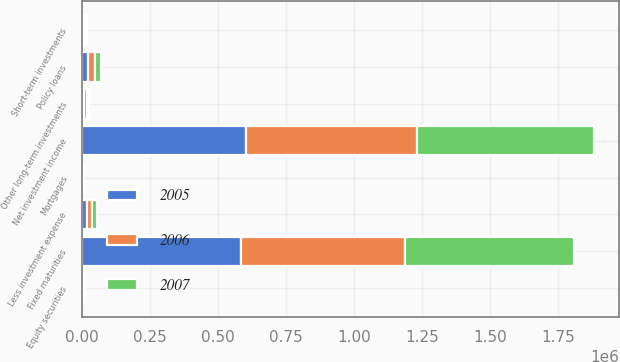Convert chart. <chart><loc_0><loc_0><loc_500><loc_500><stacked_bar_chart><ecel><fcel>Fixed maturities<fcel>Equity securities<fcel>Policy loans<fcel>Other long-term investments<fcel>Short-term investments<fcel>Less investment expense<fcel>Net investment income<fcel>Mortgages<nl><fcel>2007<fcel>621752<fcel>2827<fcel>24344<fcel>8841<fcel>9379<fcel>18317<fcel>648826<fcel>0<nl><fcel>2006<fcel>604405<fcel>3503<fcel>23328<fcel>8731<fcel>6980<fcel>18201<fcel>628746<fcel>5783<nl><fcel>2005<fcel>584198<fcel>2986<fcel>22377<fcel>7117<fcel>2882<fcel>16492<fcel>603068<fcel>0<nl></chart> 